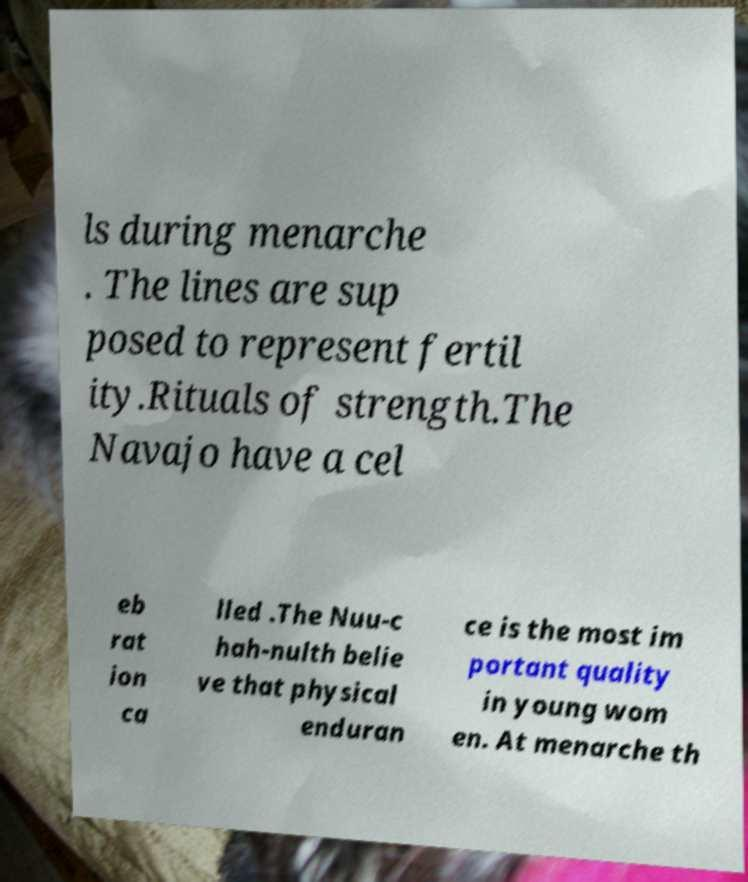I need the written content from this picture converted into text. Can you do that? ls during menarche . The lines are sup posed to represent fertil ity.Rituals of strength.The Navajo have a cel eb rat ion ca lled .The Nuu-c hah-nulth belie ve that physical enduran ce is the most im portant quality in young wom en. At menarche th 